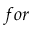Convert formula to latex. <formula><loc_0><loc_0><loc_500><loc_500>f o r</formula> 